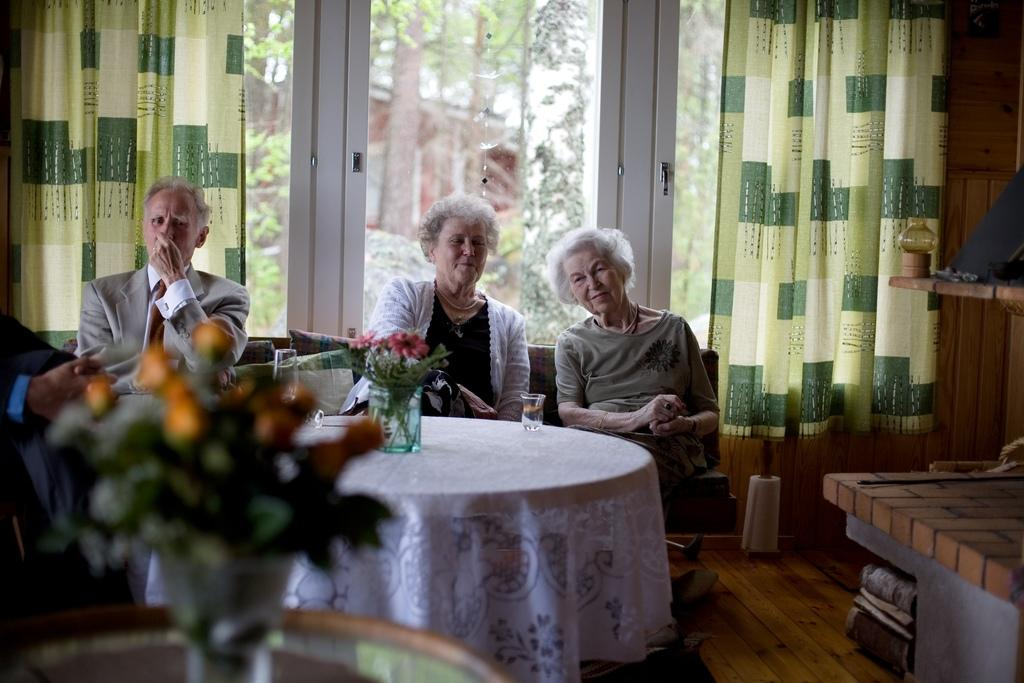Who is present in the image? There is a group of old people in the image. What are the old people doing in the image? The old people are sitting on a sofa. What is in front of the sofa? There is a table in front of the sofa. What is on the table? There is a flower vase on the table. What can be seen in the background of the image? There is a glass door in the background of the image, and curtains are hanging on the glass door. What type of tub is visible in the image? There is no tub present in the image. Who is the governor in the image? There is no mention of a governor in the image. 